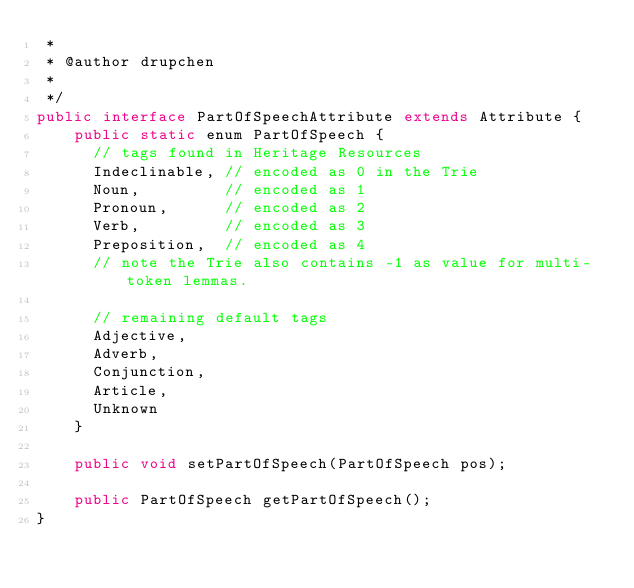<code> <loc_0><loc_0><loc_500><loc_500><_Java_> * 
 * @author drupchen
 *
 */
public interface PartOfSpeechAttribute extends Attribute {    
    public static enum PartOfSpeech {
      // tags found in Heritage Resources
      Indeclinable, // encoded as 0 in the Trie
      Noun,         // encoded as 1 
      Pronoun,      // encoded as 2
      Verb,         // encoded as 3
      Preposition,  // encoded as 4
      // note the Trie also contains -1 as value for multi-token lemmas.
      
      // remaining default tags 
      Adjective, 
      Adverb,  
      Conjunction, 
      Article, 
      Unknown
    }
  
    public void setPartOfSpeech(PartOfSpeech pos);
  
    public PartOfSpeech getPartOfSpeech();
}
</code> 